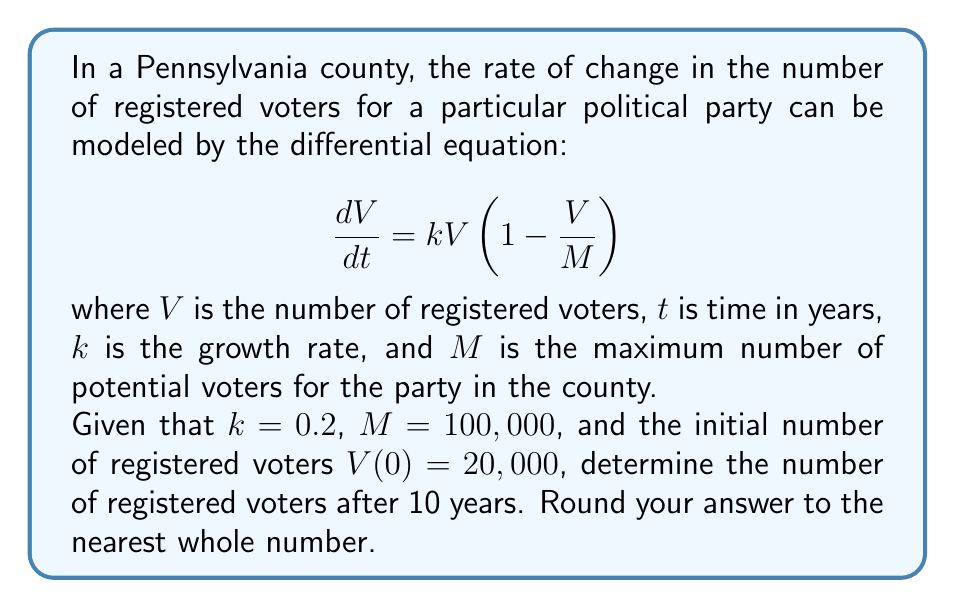Give your solution to this math problem. To solve this problem, we need to use the logistic growth model, which is described by the given differential equation. This model is often used in population dynamics and can be applied to voting pattern trends.

1) The given differential equation is:

   $$\frac{dV}{dt} = kV(1 - \frac{V}{M})$$

2) The solution to this differential equation is:

   $$V(t) = \frac{M}{1 + (\frac{M}{V_0} - 1)e^{-kt}}$$

   where $V_0$ is the initial number of voters.

3) We are given the following values:
   - $k = 0.2$
   - $M = 100,000$
   - $V_0 = 20,000$
   - $t = 10$ (we want to find the number of voters after 10 years)

4) Let's substitute these values into the solution:

   $$V(10) = \frac{100,000}{1 + (\frac{100,000}{20,000} - 1)e^{-0.2(10)}}$$

5) Simplify:
   
   $$V(10) = \frac{100,000}{1 + (5 - 1)e^{-2}}$$
   
   $$V(10) = \frac{100,000}{1 + 4e^{-2}}$$

6) Calculate $e^{-2}$:
   
   $$e^{-2} \approx 0.1353$$

7) Substitute this value:

   $$V(10) = \frac{100,000}{1 + 4(0.1353)} = \frac{100,000}{1.5412}$$

8) Calculate the final result:

   $$V(10) \approx 64,885.15$$

9) Rounding to the nearest whole number:

   $$V(10) \approx 64,885$$
Answer: 64,885 registered voters 